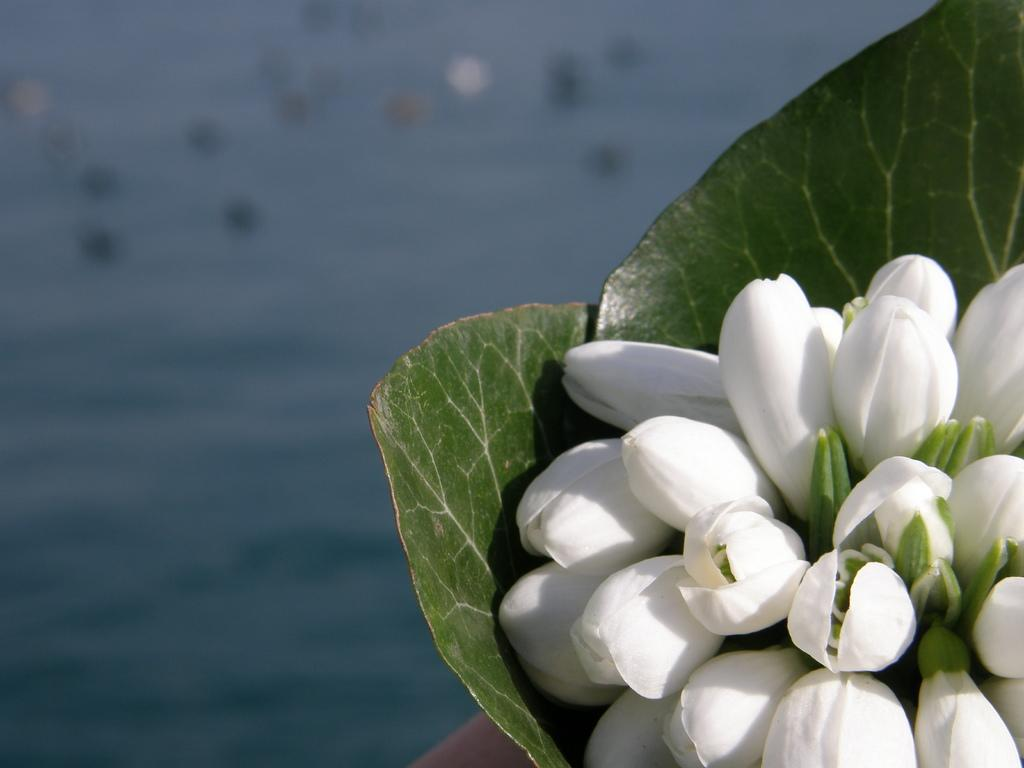What type of plants can be seen in the image? The image contains flowers. What is visible at the bottom of the image? There is water visible at the bottom of the image. What part of the plants is green in the image? Green leaves are present in the image. What type of vegetable is being used as a pipe in the image? There is no vegetable or pipe present in the image; it features flowers and water. 